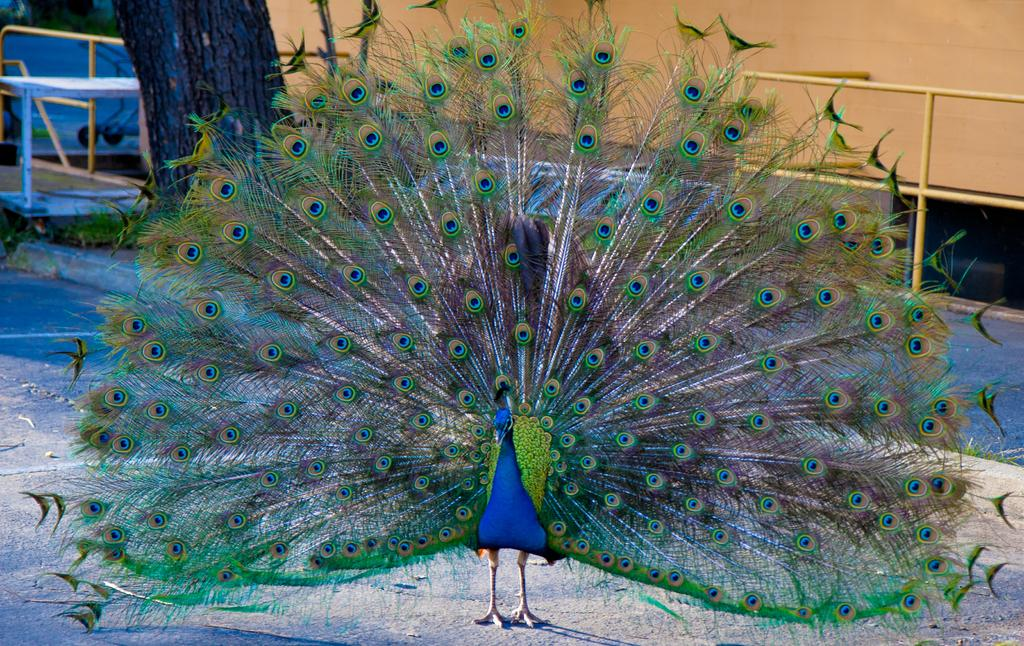What animal is on the ground in the image? There is a peacock on the ground in the image. What type of vegetation is visible in the image? There is a tree visible in the image. What can be seen in the background of the image? There appears to be a cloth in the background of the image. What type of bed is visible under the peacock in the image? There is no bed visible in the image; the peacock is on the ground. 